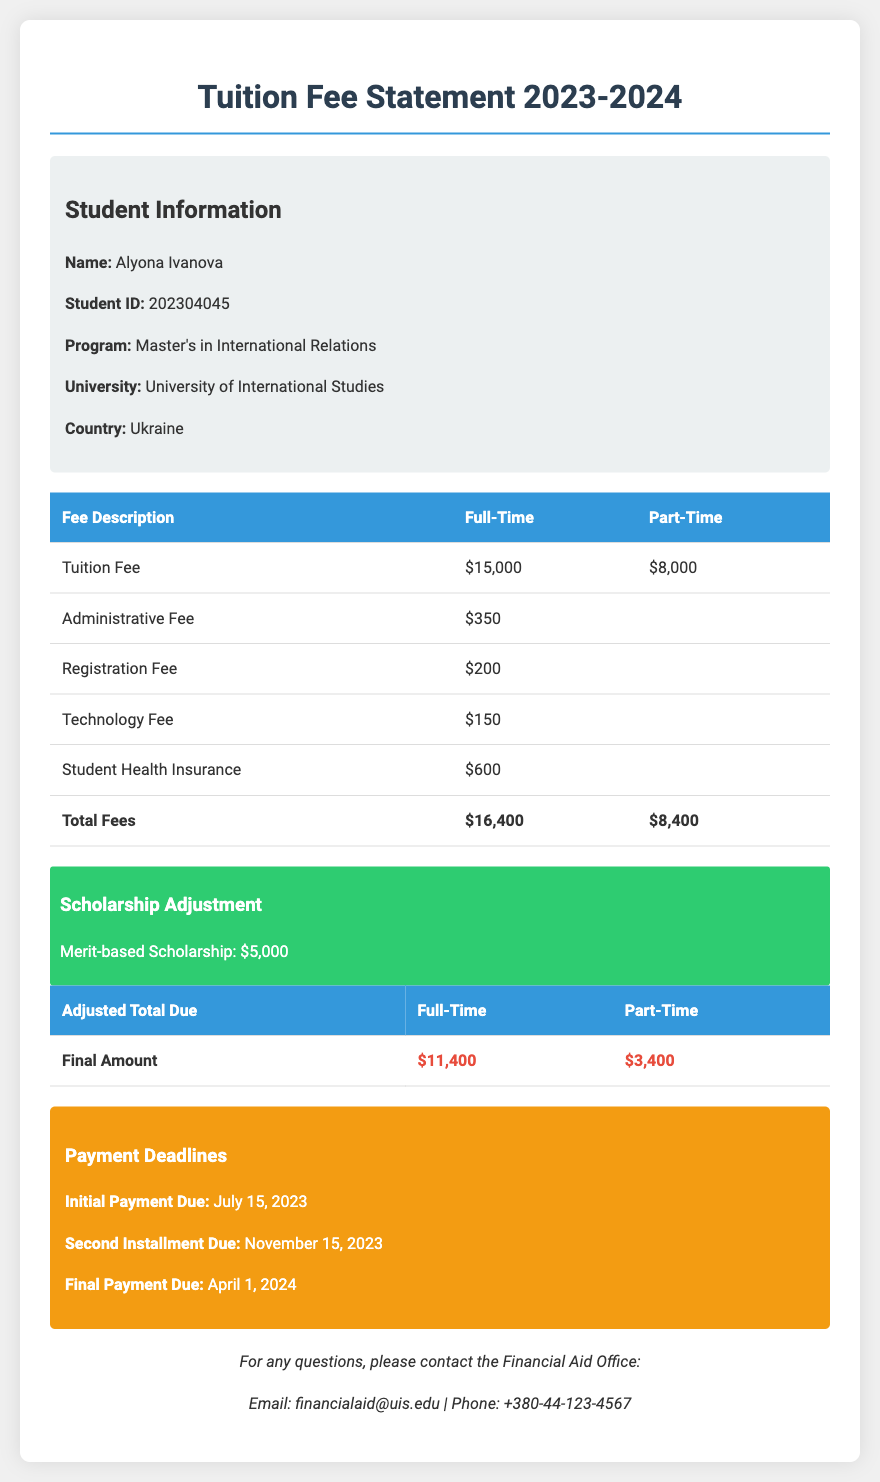What is the full-time tuition fee? The full-time tuition fee is specified in the document as $15,000.
Answer: $15,000 What is the scholarship amount? The scholarship adjustment is listed in the document as a merit-based scholarship of $5,000.
Answer: $5,000 When is the final payment due? The document states that the final payment is due on April 1, 2024.
Answer: April 1, 2024 What is the total adjusted amount due for part-time students? The document shows that the final amount due for part-time students is $3,400 after adjustments.
Answer: $3,400 What is the administrative fee? The administrative fee listed in the document is $350.
Answer: $350 How much is the technology fee? The document provides the technology fee as $150.
Answer: $150 What is the student's program? The program mentioned in the document is a Master's in International Relations.
Answer: Master's in International Relations What is the due date for the second installment? According to the document, the second installment is due on November 15, 2023.
Answer: November 15, 2023 What is the student's name? The document identifies the student's name as Alyona Ivanova.
Answer: Alyona Ivanova 